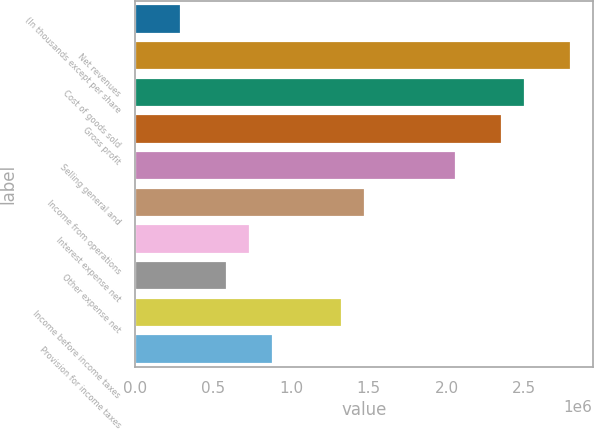Convert chart. <chart><loc_0><loc_0><loc_500><loc_500><bar_chart><fcel>(In thousands except per share<fcel>Net revenues<fcel>Cost of goods sold<fcel>Gross profit<fcel>Selling general and<fcel>Income from operations<fcel>Interest expense net<fcel>Other expense net<fcel>Income before income taxes<fcel>Provision for income taxes<nl><fcel>294537<fcel>2.7981e+06<fcel>2.50356e+06<fcel>2.35629e+06<fcel>2.06176e+06<fcel>1.47268e+06<fcel>736342<fcel>589074<fcel>1.32542e+06<fcel>883611<nl></chart> 